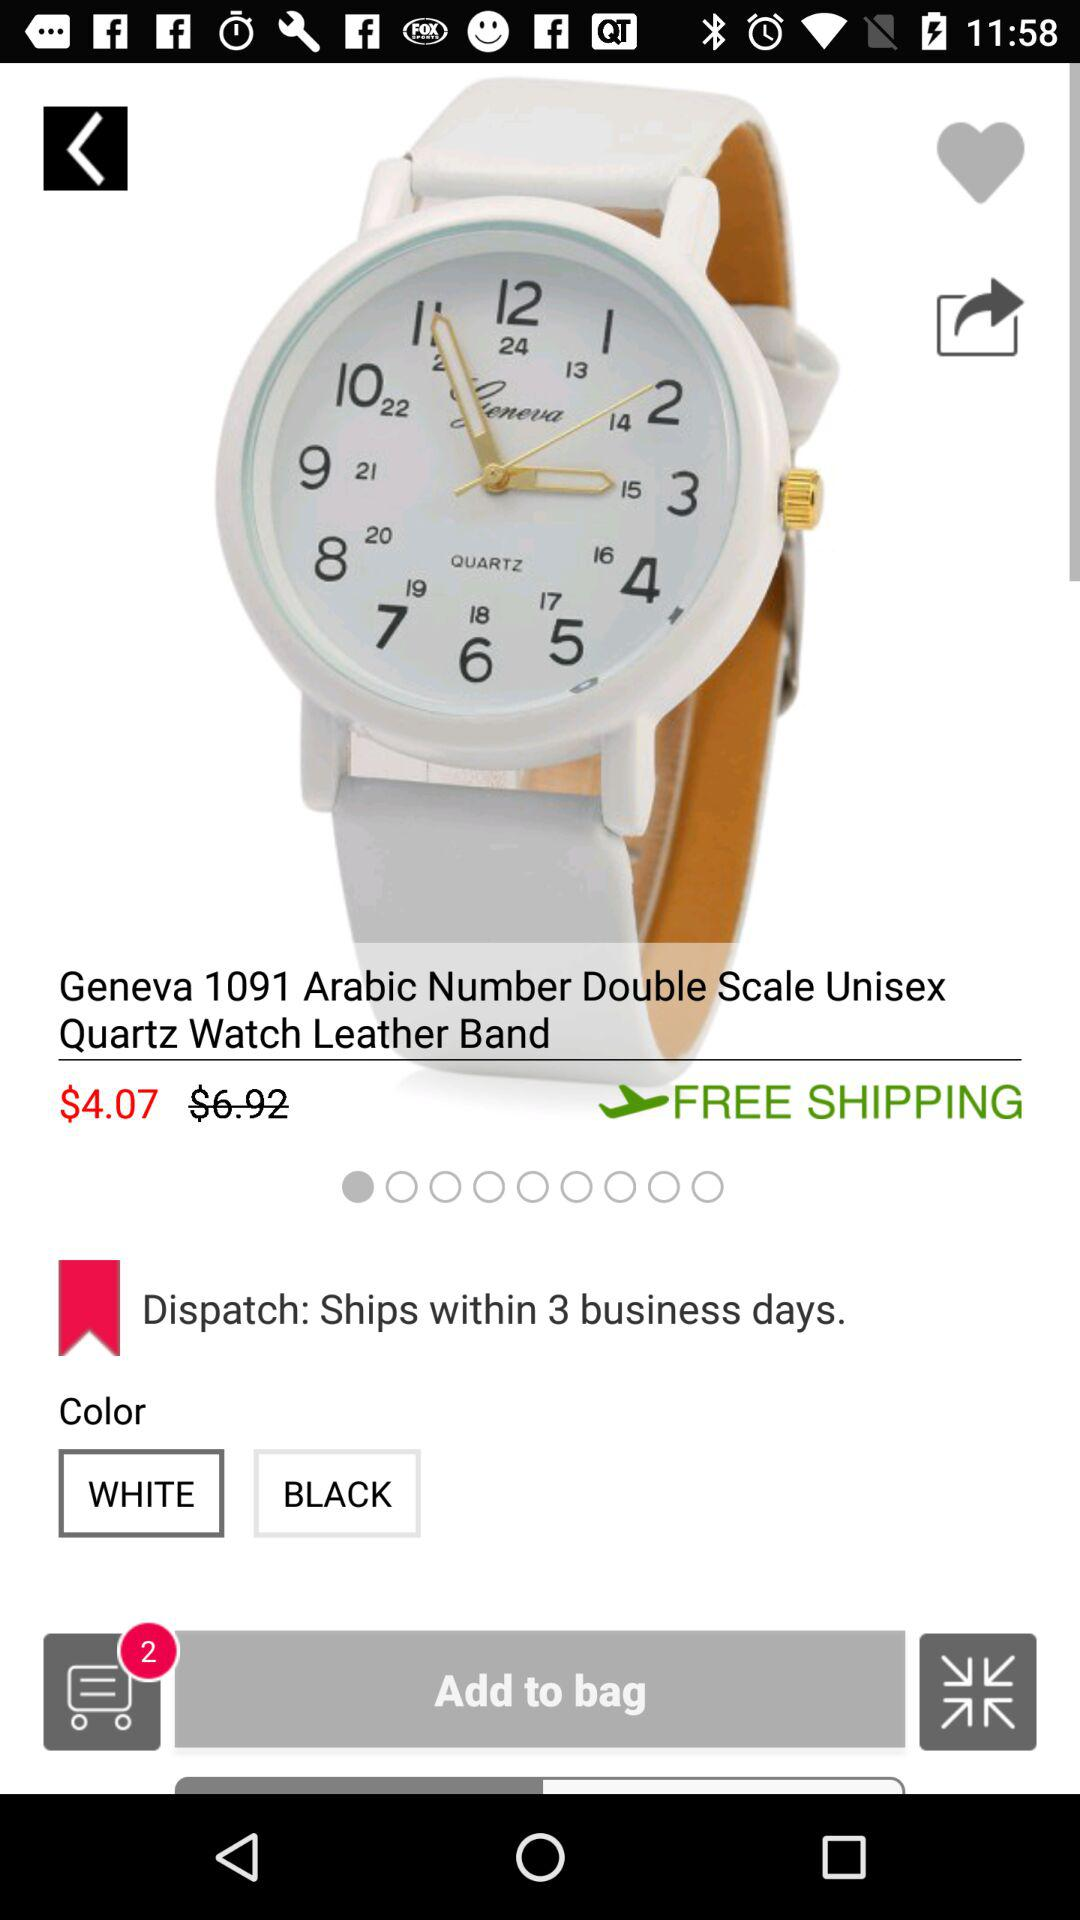Which watch color is selected? The selected watch color is white. 